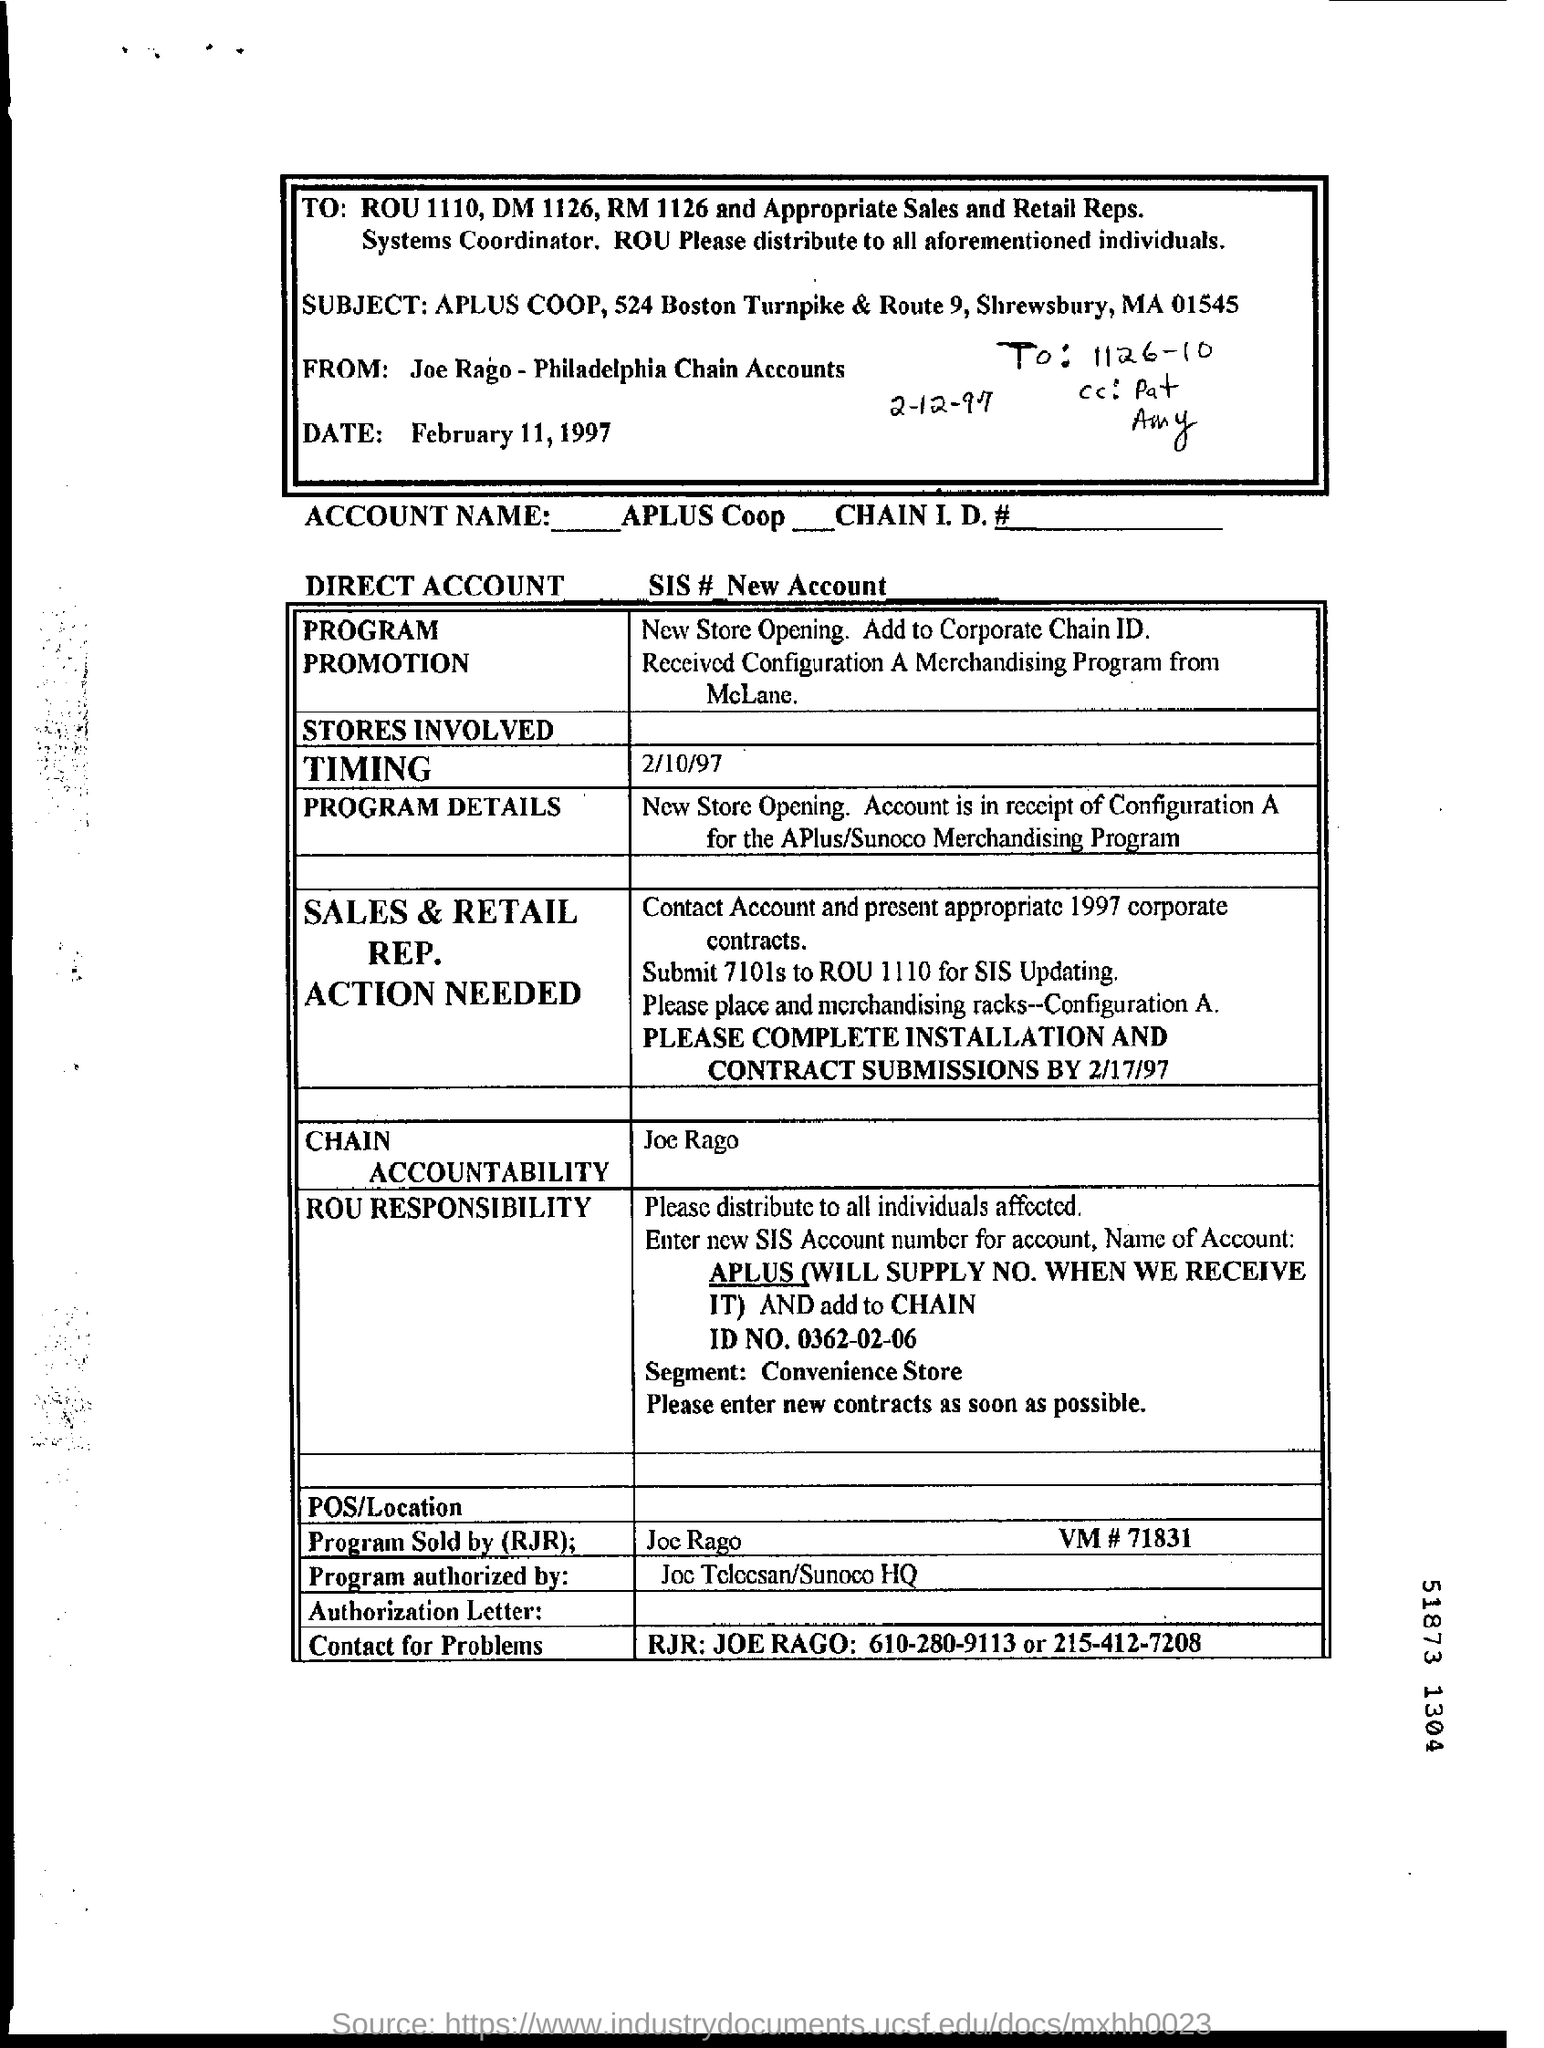Mention a couple of crucial points in this snapshot. The form is dated February 11, 1997. 